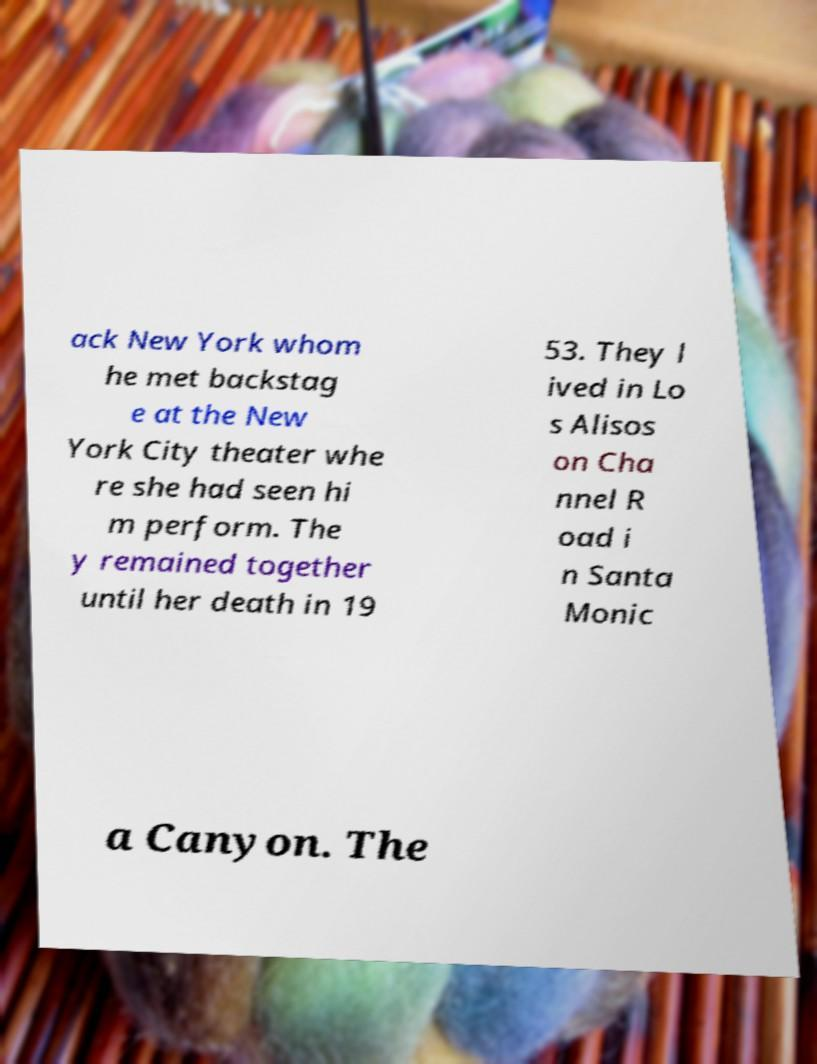There's text embedded in this image that I need extracted. Can you transcribe it verbatim? ack New York whom he met backstag e at the New York City theater whe re she had seen hi m perform. The y remained together until her death in 19 53. They l ived in Lo s Alisos on Cha nnel R oad i n Santa Monic a Canyon. The 